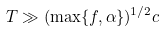Convert formula to latex. <formula><loc_0><loc_0><loc_500><loc_500>T \gg ( \max \{ f , \alpha \} ) ^ { 1 / 2 } c</formula> 